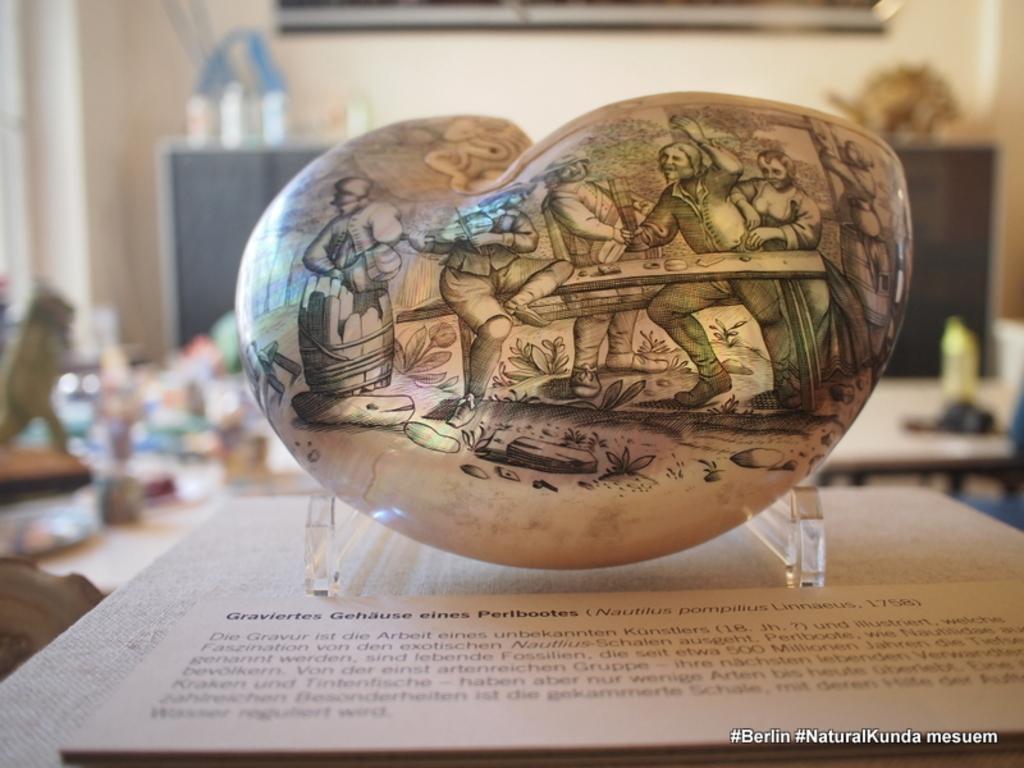Could you give a brief overview of what you see in this image? In this picture there is a stone kept on table and on the stone I can see image of persons , in front of stone I can see a text visible on board , in the background it might be the wall and sculpture kept on table visible. 